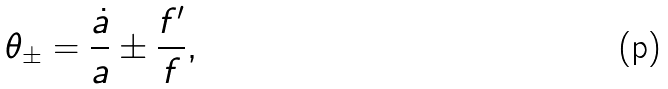<formula> <loc_0><loc_0><loc_500><loc_500>\theta _ { \pm } = \frac { \dot { a } } { a } \pm \frac { f ^ { \prime } } { f } ,</formula> 